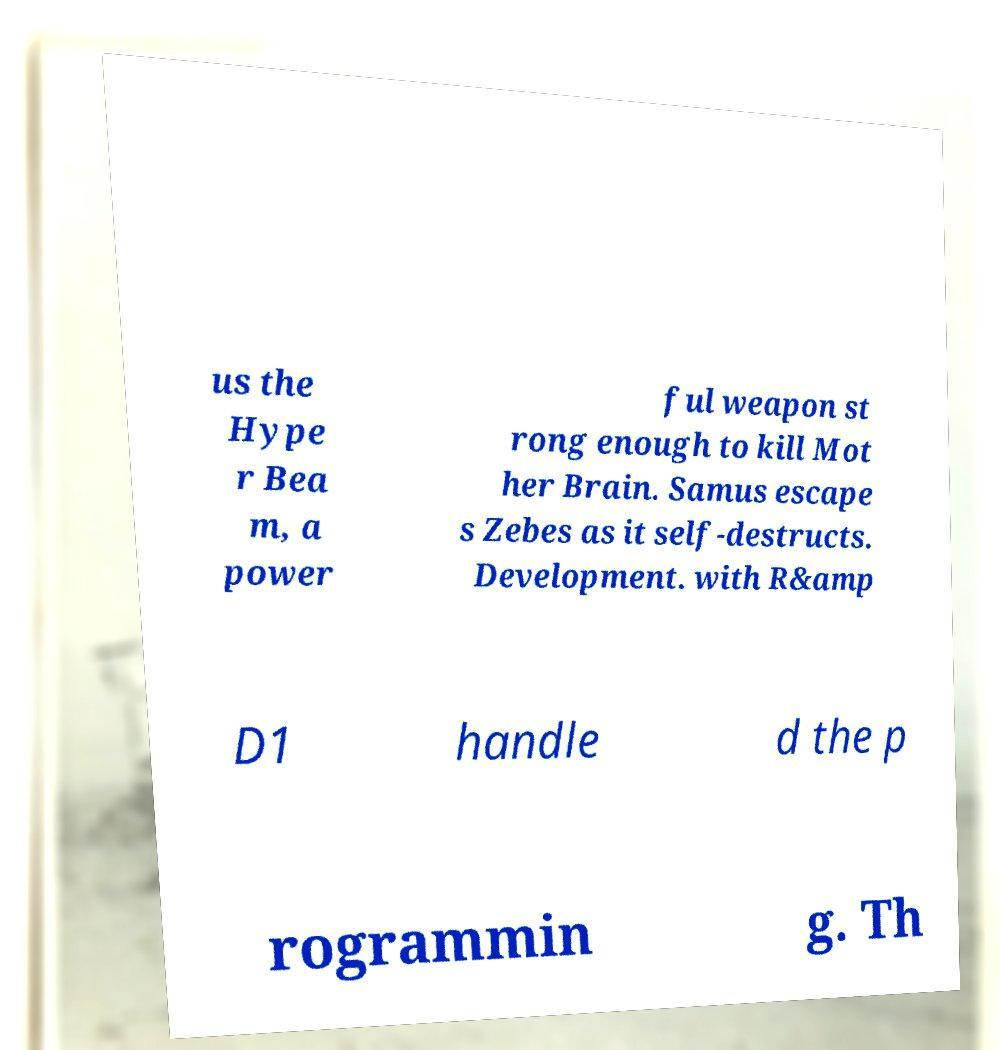What messages or text are displayed in this image? I need them in a readable, typed format. us the Hype r Bea m, a power ful weapon st rong enough to kill Mot her Brain. Samus escape s Zebes as it self-destructs. Development. with R&amp D1 handle d the p rogrammin g. Th 